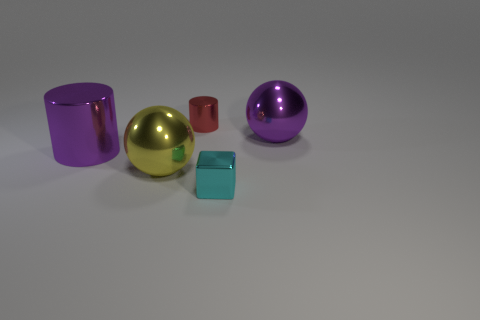Add 3 tiny cyan metal blocks. How many objects exist? 8 Subtract all blocks. How many objects are left? 4 Add 4 cylinders. How many cylinders are left? 6 Add 5 cyan rubber spheres. How many cyan rubber spheres exist? 5 Subtract 0 yellow cubes. How many objects are left? 5 Subtract all yellow objects. Subtract all purple shiny cylinders. How many objects are left? 3 